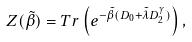Convert formula to latex. <formula><loc_0><loc_0><loc_500><loc_500>Z ( \tilde { \beta } ) = T r \left ( e ^ { - \tilde { \beta } ( D _ { 0 } + \tilde { \lambda } D _ { 2 } ^ { \gamma } ) } \right ) ,</formula> 